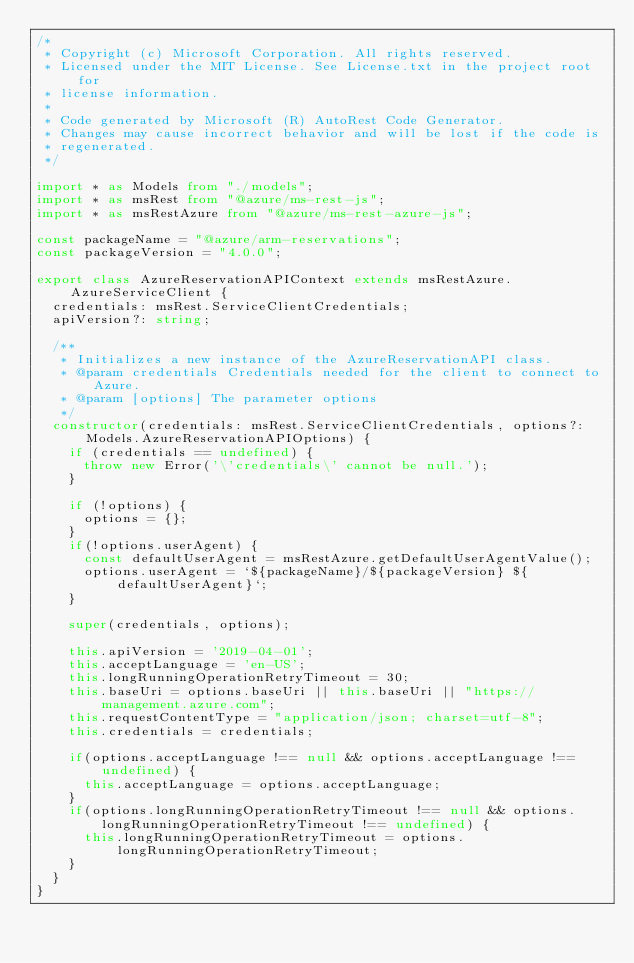<code> <loc_0><loc_0><loc_500><loc_500><_TypeScript_>/*
 * Copyright (c) Microsoft Corporation. All rights reserved.
 * Licensed under the MIT License. See License.txt in the project root for
 * license information.
 *
 * Code generated by Microsoft (R) AutoRest Code Generator.
 * Changes may cause incorrect behavior and will be lost if the code is
 * regenerated.
 */

import * as Models from "./models";
import * as msRest from "@azure/ms-rest-js";
import * as msRestAzure from "@azure/ms-rest-azure-js";

const packageName = "@azure/arm-reservations";
const packageVersion = "4.0.0";

export class AzureReservationAPIContext extends msRestAzure.AzureServiceClient {
  credentials: msRest.ServiceClientCredentials;
  apiVersion?: string;

  /**
   * Initializes a new instance of the AzureReservationAPI class.
   * @param credentials Credentials needed for the client to connect to Azure.
   * @param [options] The parameter options
   */
  constructor(credentials: msRest.ServiceClientCredentials, options?: Models.AzureReservationAPIOptions) {
    if (credentials == undefined) {
      throw new Error('\'credentials\' cannot be null.');
    }

    if (!options) {
      options = {};
    }
    if(!options.userAgent) {
      const defaultUserAgent = msRestAzure.getDefaultUserAgentValue();
      options.userAgent = `${packageName}/${packageVersion} ${defaultUserAgent}`;
    }

    super(credentials, options);

    this.apiVersion = '2019-04-01';
    this.acceptLanguage = 'en-US';
    this.longRunningOperationRetryTimeout = 30;
    this.baseUri = options.baseUri || this.baseUri || "https://management.azure.com";
    this.requestContentType = "application/json; charset=utf-8";
    this.credentials = credentials;

    if(options.acceptLanguage !== null && options.acceptLanguage !== undefined) {
      this.acceptLanguage = options.acceptLanguage;
    }
    if(options.longRunningOperationRetryTimeout !== null && options.longRunningOperationRetryTimeout !== undefined) {
      this.longRunningOperationRetryTimeout = options.longRunningOperationRetryTimeout;
    }
  }
}
</code> 